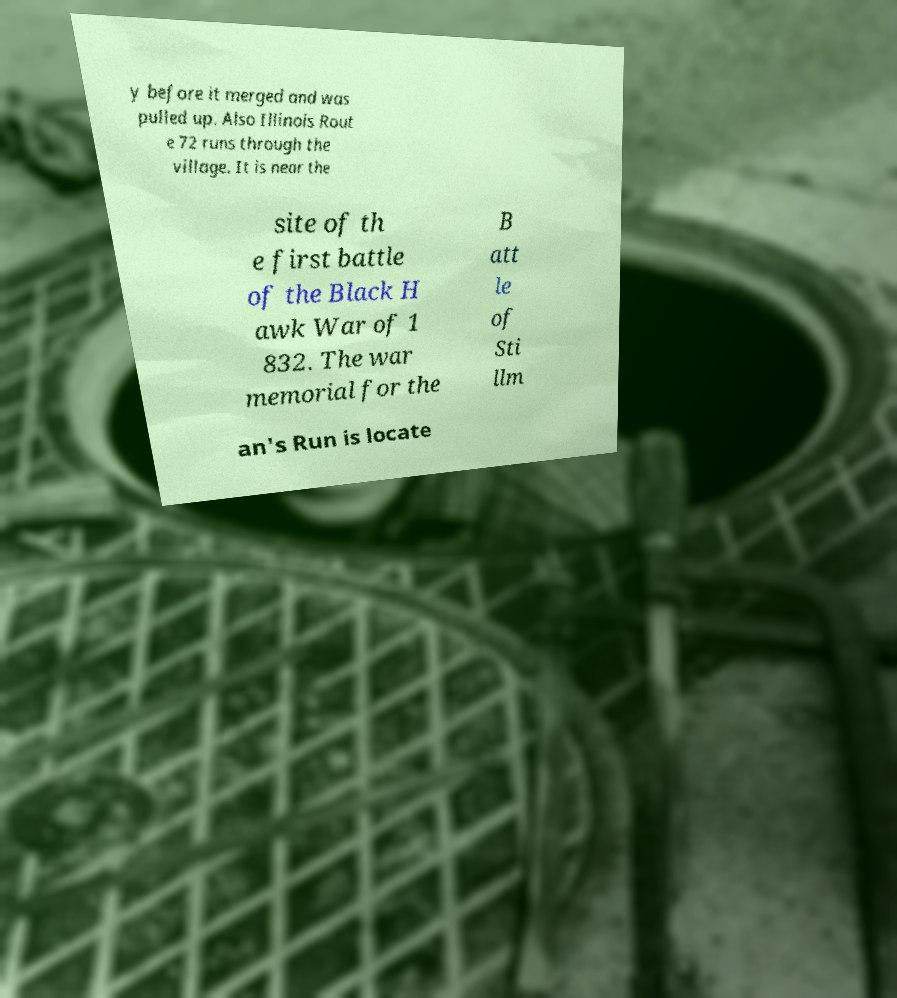Could you assist in decoding the text presented in this image and type it out clearly? y before it merged and was pulled up. Also Illinois Rout e 72 runs through the village. It is near the site of th e first battle of the Black H awk War of 1 832. The war memorial for the B att le of Sti llm an's Run is locate 